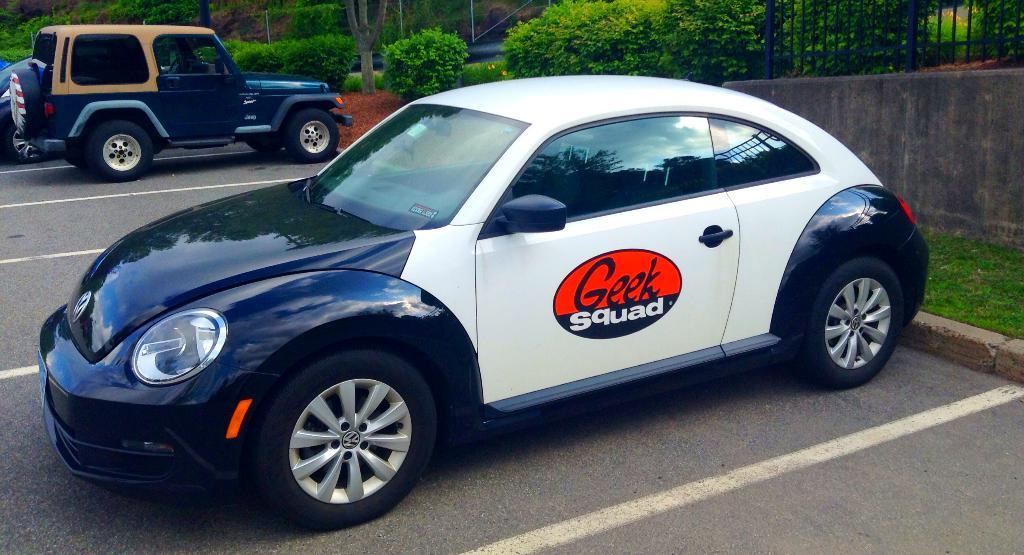What can be seen in the parking space in the image? There are cars parked in the parking space. What is visible in the backdrop of the image? There are plants and trees in the backdrop. Are there any icicles hanging from the trees in the image? There are no icicles visible in the image, as the trees and plants appear to be in a normal, non-frozen state. 